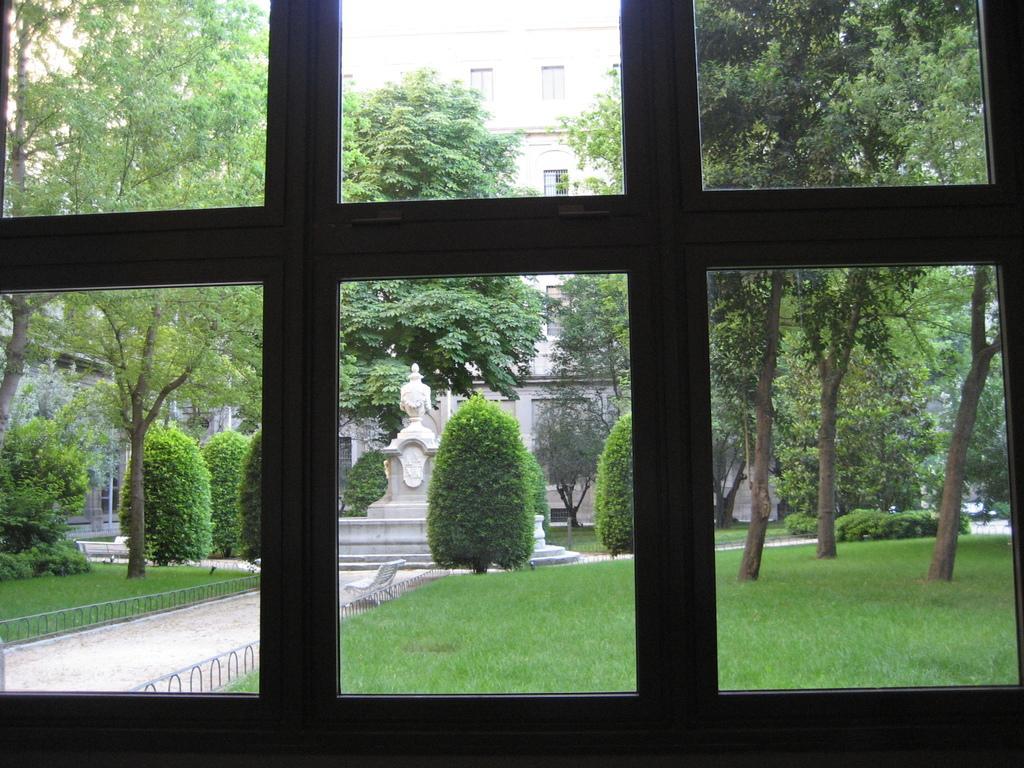In one or two sentences, can you explain what this image depicts? In this image in the foreground there is a window and through the window we could see some trees, buildings, plants, grass, railing, fountain and a walkway. 